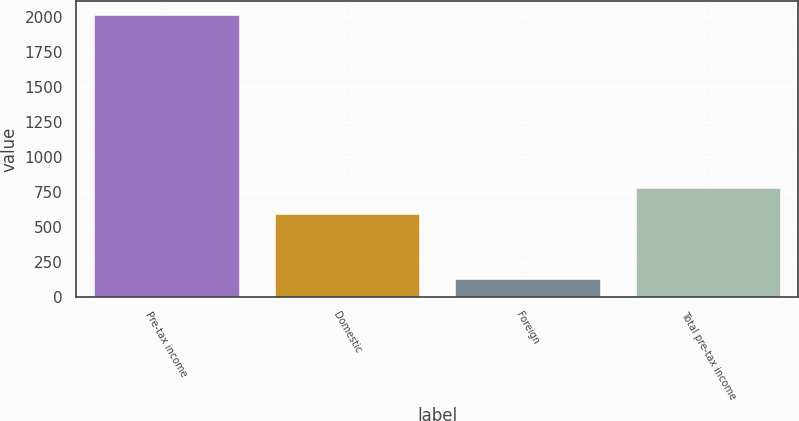<chart> <loc_0><loc_0><loc_500><loc_500><bar_chart><fcel>Pre-tax income<fcel>Domestic<fcel>Foreign<fcel>Total pre-tax income<nl><fcel>2015<fcel>593.5<fcel>132.5<fcel>781.75<nl></chart> 